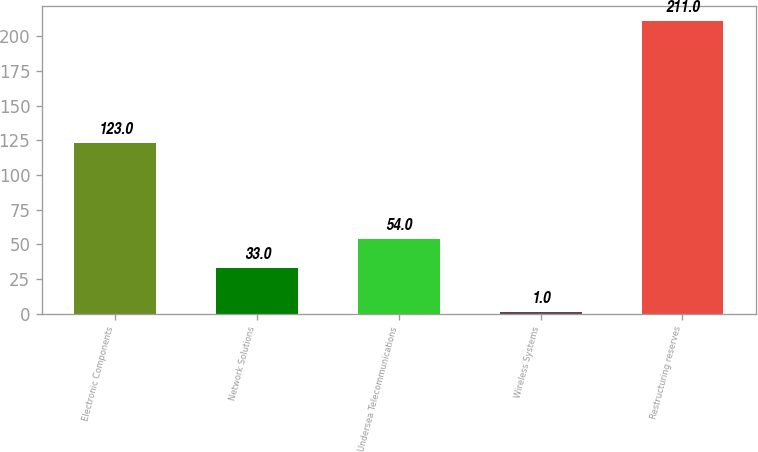<chart> <loc_0><loc_0><loc_500><loc_500><bar_chart><fcel>Electronic Components<fcel>Network Solutions<fcel>Undersea Telecommunications<fcel>Wireless Systems<fcel>Restructuring reserves<nl><fcel>123<fcel>33<fcel>54<fcel>1<fcel>211<nl></chart> 